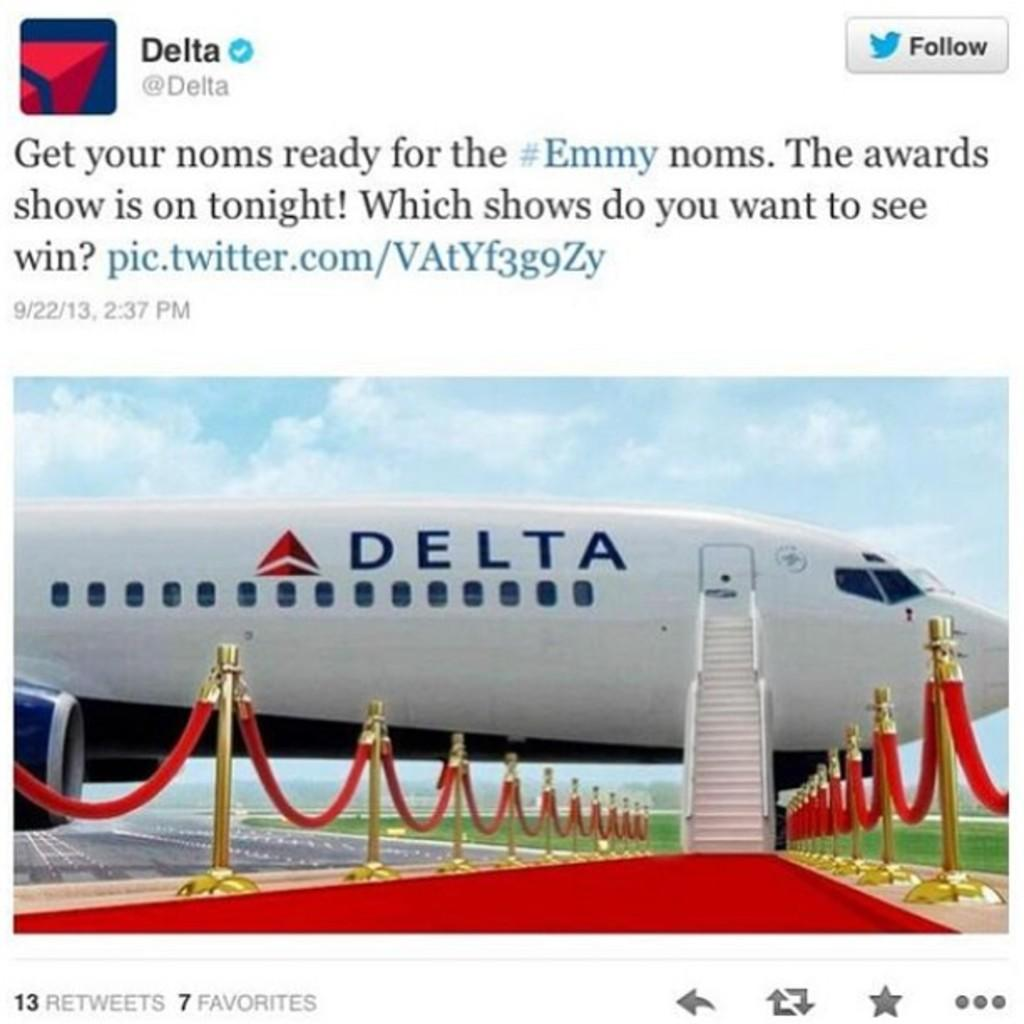<image>
Render a clear and concise summary of the photo. A Delta plane waiting to be boarded at the end of a red carpet. 